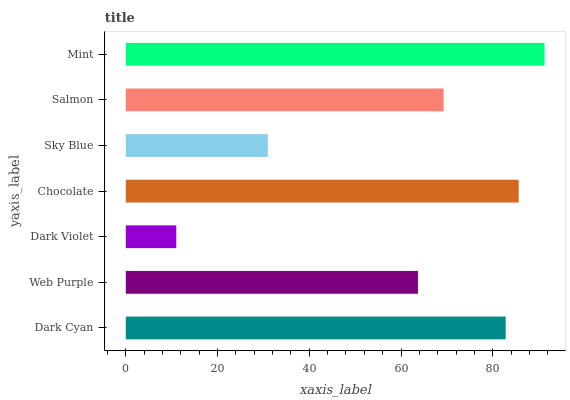Is Dark Violet the minimum?
Answer yes or no. Yes. Is Mint the maximum?
Answer yes or no. Yes. Is Web Purple the minimum?
Answer yes or no. No. Is Web Purple the maximum?
Answer yes or no. No. Is Dark Cyan greater than Web Purple?
Answer yes or no. Yes. Is Web Purple less than Dark Cyan?
Answer yes or no. Yes. Is Web Purple greater than Dark Cyan?
Answer yes or no. No. Is Dark Cyan less than Web Purple?
Answer yes or no. No. Is Salmon the high median?
Answer yes or no. Yes. Is Salmon the low median?
Answer yes or no. Yes. Is Mint the high median?
Answer yes or no. No. Is Web Purple the low median?
Answer yes or no. No. 